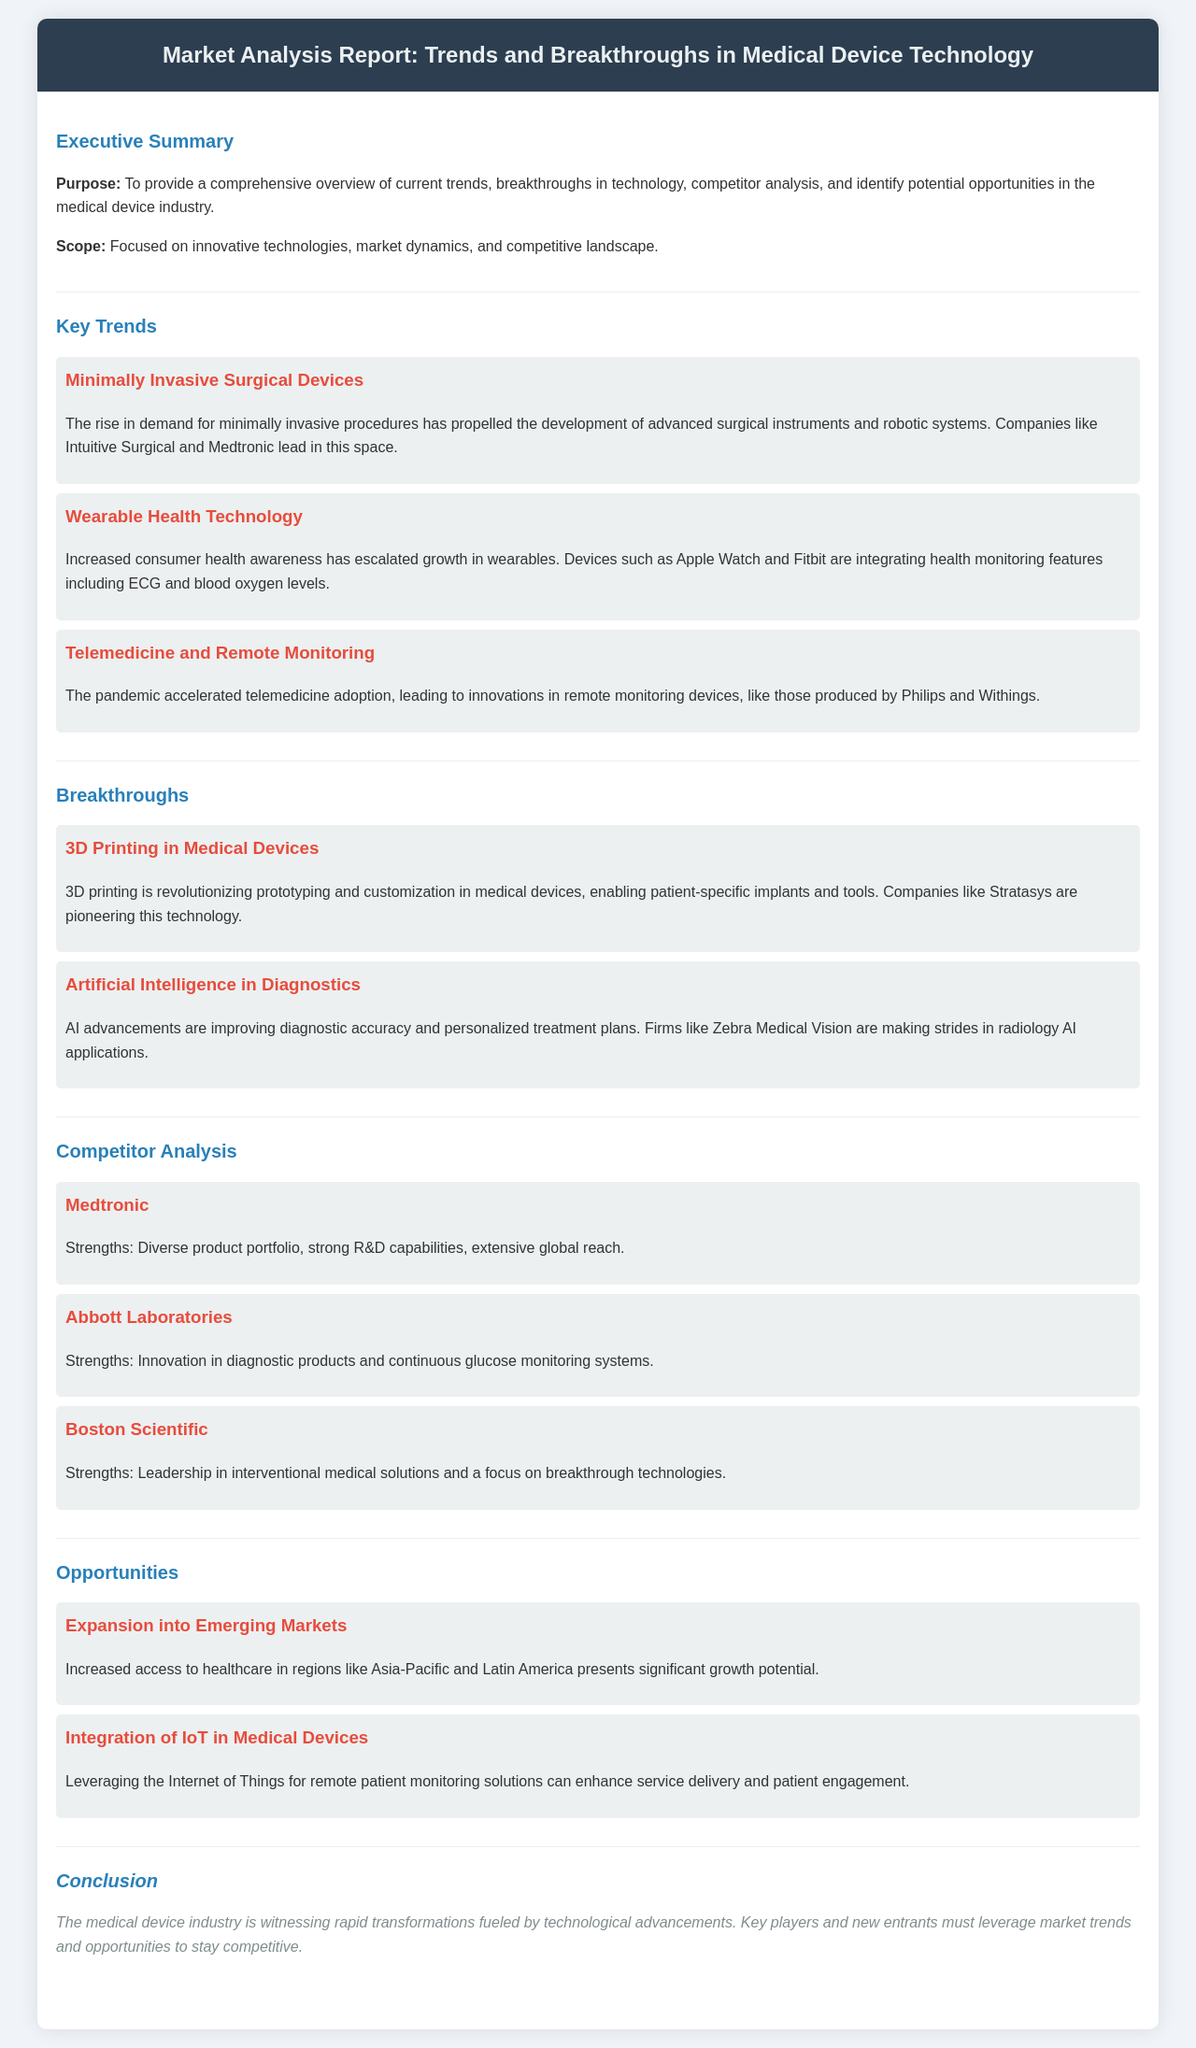What is the purpose of the report? The purpose of the report is to provide a comprehensive overview of current trends, breakthroughs in technology, competitor analysis, and identify potential opportunities in the medical device industry.
Answer: Comprehensive overview Who are the key players in minimally invasive surgical devices? The companies leading in minimally invasive surgical devices include Intuitive Surgical and Medtronic.
Answer: Intuitive Surgical and Medtronic What breakthrough technology is mentioned for customization in medical devices? The breakthrough technology mentioned for customization is 3D printing.
Answer: 3D printing Which competitor is noted for strong R&D capabilities? Medtronic is noted for its diverse product portfolio, strong R&D capabilities, and extensive global reach.
Answer: Medtronic What opportunity is highlighted for growth in healthcare? The opportunity highlighted for growth in healthcare is the expansion into emerging markets.
Answer: Expansion into emerging markets Which company is recognized for innovation in diagnostic products? Abbott Laboratories is recognized for innovation in diagnostic products and continuous glucose monitoring systems.
Answer: Abbott Laboratories What technological integration is suggested for enhancing patient engagement? The integration of IoT in medical devices is suggested for enhancing service delivery and patient engagement.
Answer: Integration of IoT Which health monitoring features are integrated into wearables? Wearables like Apple Watch and Fitbit integrate health monitoring features including ECG and blood oxygen levels.
Answer: ECG and blood oxygen levels 